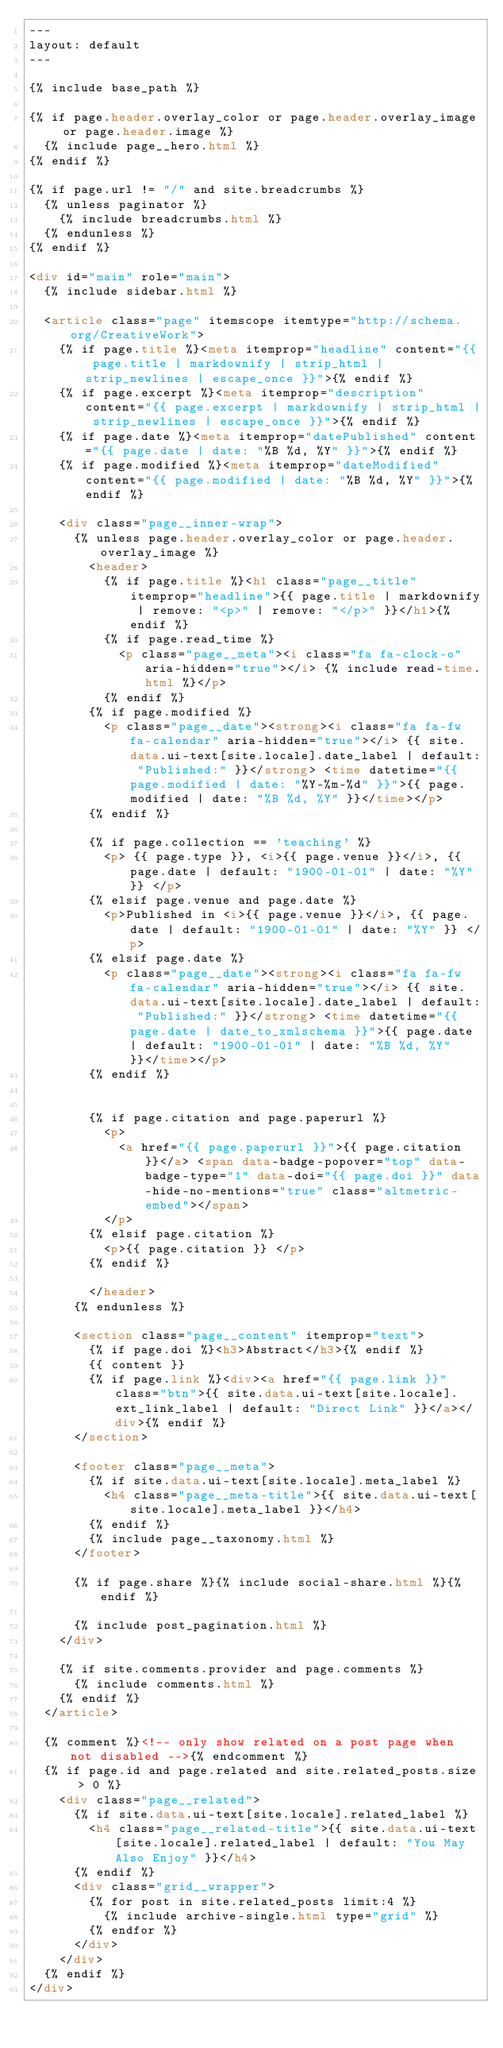<code> <loc_0><loc_0><loc_500><loc_500><_HTML_>---
layout: default
---

{% include base_path %}

{% if page.header.overlay_color or page.header.overlay_image or page.header.image %}
  {% include page__hero.html %}
{% endif %}

{% if page.url != "/" and site.breadcrumbs %}
  {% unless paginator %}
    {% include breadcrumbs.html %}
  {% endunless %}
{% endif %}

<div id="main" role="main">
  {% include sidebar.html %}

  <article class="page" itemscope itemtype="http://schema.org/CreativeWork">
    {% if page.title %}<meta itemprop="headline" content="{{ page.title | markdownify | strip_html | strip_newlines | escape_once }}">{% endif %}
    {% if page.excerpt %}<meta itemprop="description" content="{{ page.excerpt | markdownify | strip_html | strip_newlines | escape_once }}">{% endif %}
    {% if page.date %}<meta itemprop="datePublished" content="{{ page.date | date: "%B %d, %Y" }}">{% endif %}
    {% if page.modified %}<meta itemprop="dateModified" content="{{ page.modified | date: "%B %d, %Y" }}">{% endif %}

    <div class="page__inner-wrap">
      {% unless page.header.overlay_color or page.header.overlay_image %}
        <header>
          {% if page.title %}<h1 class="page__title" itemprop="headline">{{ page.title | markdownify | remove: "<p>" | remove: "</p>" }}</h1>{% endif %}
          {% if page.read_time %}
            <p class="page__meta"><i class="fa fa-clock-o" aria-hidden="true"></i> {% include read-time.html %}</p>
          {% endif %}
        {% if page.modified %}
          <p class="page__date"><strong><i class="fa fa-fw fa-calendar" aria-hidden="true"></i> {{ site.data.ui-text[site.locale].date_label | default: "Published:" }}</strong> <time datetime="{{ page.modified | date: "%Y-%m-%d" }}">{{ page.modified | date: "%B %d, %Y" }}</time></p>
        {% endif %}

        {% if page.collection == 'teaching' %}
          <p> {{ page.type }}, <i>{{ page.venue }}</i>, {{ page.date | default: "1900-01-01" | date: "%Y" }} </p>
        {% elsif page.venue and page.date %}
          <p>Published in <i>{{ page.venue }}</i>, {{ page.date | default: "1900-01-01" | date: "%Y" }} </p>
        {% elsif page.date %}
          <p class="page__date"><strong><i class="fa fa-fw fa-calendar" aria-hidden="true"></i> {{ site.data.ui-text[site.locale].date_label | default: "Published:" }}</strong> <time datetime="{{ page.date | date_to_xmlschema }}">{{ page.date | default: "1900-01-01" | date: "%B %d, %Y" }}</time></p>
        {% endif %}


        {% if page.citation and page.paperurl %}
          <p>
            <a href="{{ page.paperurl }}">{{ page.citation }}</a> <span data-badge-popover="top" data-badge-type="1" data-doi="{{ page.doi }}" data-hide-no-mentions="true" class="altmetric-embed"></span>
          </p>
        {% elsif page.citation %}
          <p>{{ page.citation }} </p>
        {% endif %}

        </header>
      {% endunless %}

      <section class="page__content" itemprop="text">
        {% if page.doi %}<h3>Abstract</h3>{% endif %}
        {{ content }}
        {% if page.link %}<div><a href="{{ page.link }}" class="btn">{{ site.data.ui-text[site.locale].ext_link_label | default: "Direct Link" }}</a></div>{% endif %}
      </section>

      <footer class="page__meta">
        {% if site.data.ui-text[site.locale].meta_label %}
          <h4 class="page__meta-title">{{ site.data.ui-text[site.locale].meta_label }}</h4>
        {% endif %}
        {% include page__taxonomy.html %}
      </footer>

      {% if page.share %}{% include social-share.html %}{% endif %}

      {% include post_pagination.html %}
    </div>

    {% if site.comments.provider and page.comments %}
      {% include comments.html %}
    {% endif %}
  </article>

  {% comment %}<!-- only show related on a post page when not disabled -->{% endcomment %}
  {% if page.id and page.related and site.related_posts.size > 0 %}
    <div class="page__related">
      {% if site.data.ui-text[site.locale].related_label %}
        <h4 class="page__related-title">{{ site.data.ui-text[site.locale].related_label | default: "You May Also Enjoy" }}</h4>
      {% endif %}
      <div class="grid__wrapper">
        {% for post in site.related_posts limit:4 %}
          {% include archive-single.html type="grid" %}
        {% endfor %}
      </div>
    </div>
  {% endif %}
</div>
</code> 